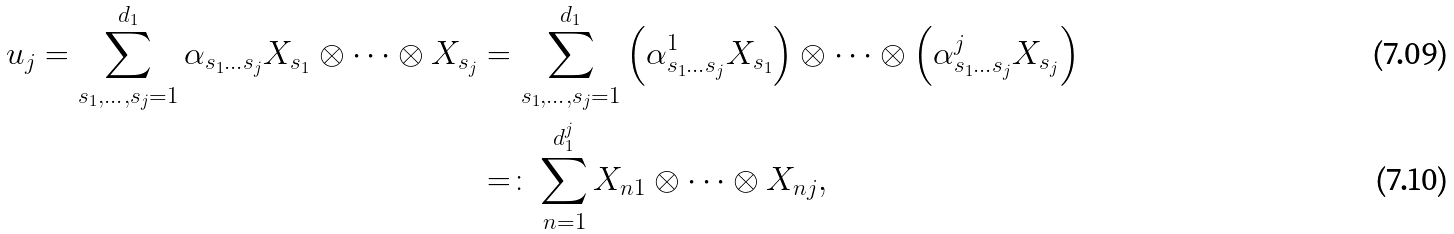Convert formula to latex. <formula><loc_0><loc_0><loc_500><loc_500>u _ { j } = \sum _ { s _ { 1 } , \dots , s _ { j } = 1 } ^ { d _ { 1 } } \alpha _ { s _ { 1 } \dots s _ { j } } X _ { s _ { 1 } } \otimes \cdots \otimes X _ { s _ { j } } & = \sum _ { s _ { 1 } , \dots , s _ { j } = 1 } ^ { d _ { 1 } } \left ( \alpha _ { s _ { 1 } \dots s _ { j } } ^ { 1 } X _ { s _ { 1 } } \right ) \otimes \cdots \otimes \left ( \alpha _ { s _ { 1 } \dots s _ { j } } ^ { j } X _ { s _ { j } } \right ) \\ & = \colon \sum _ { n = 1 } ^ { d _ { 1 } ^ { j } } X _ { n 1 } \otimes \cdots \otimes X _ { n j } ,</formula> 